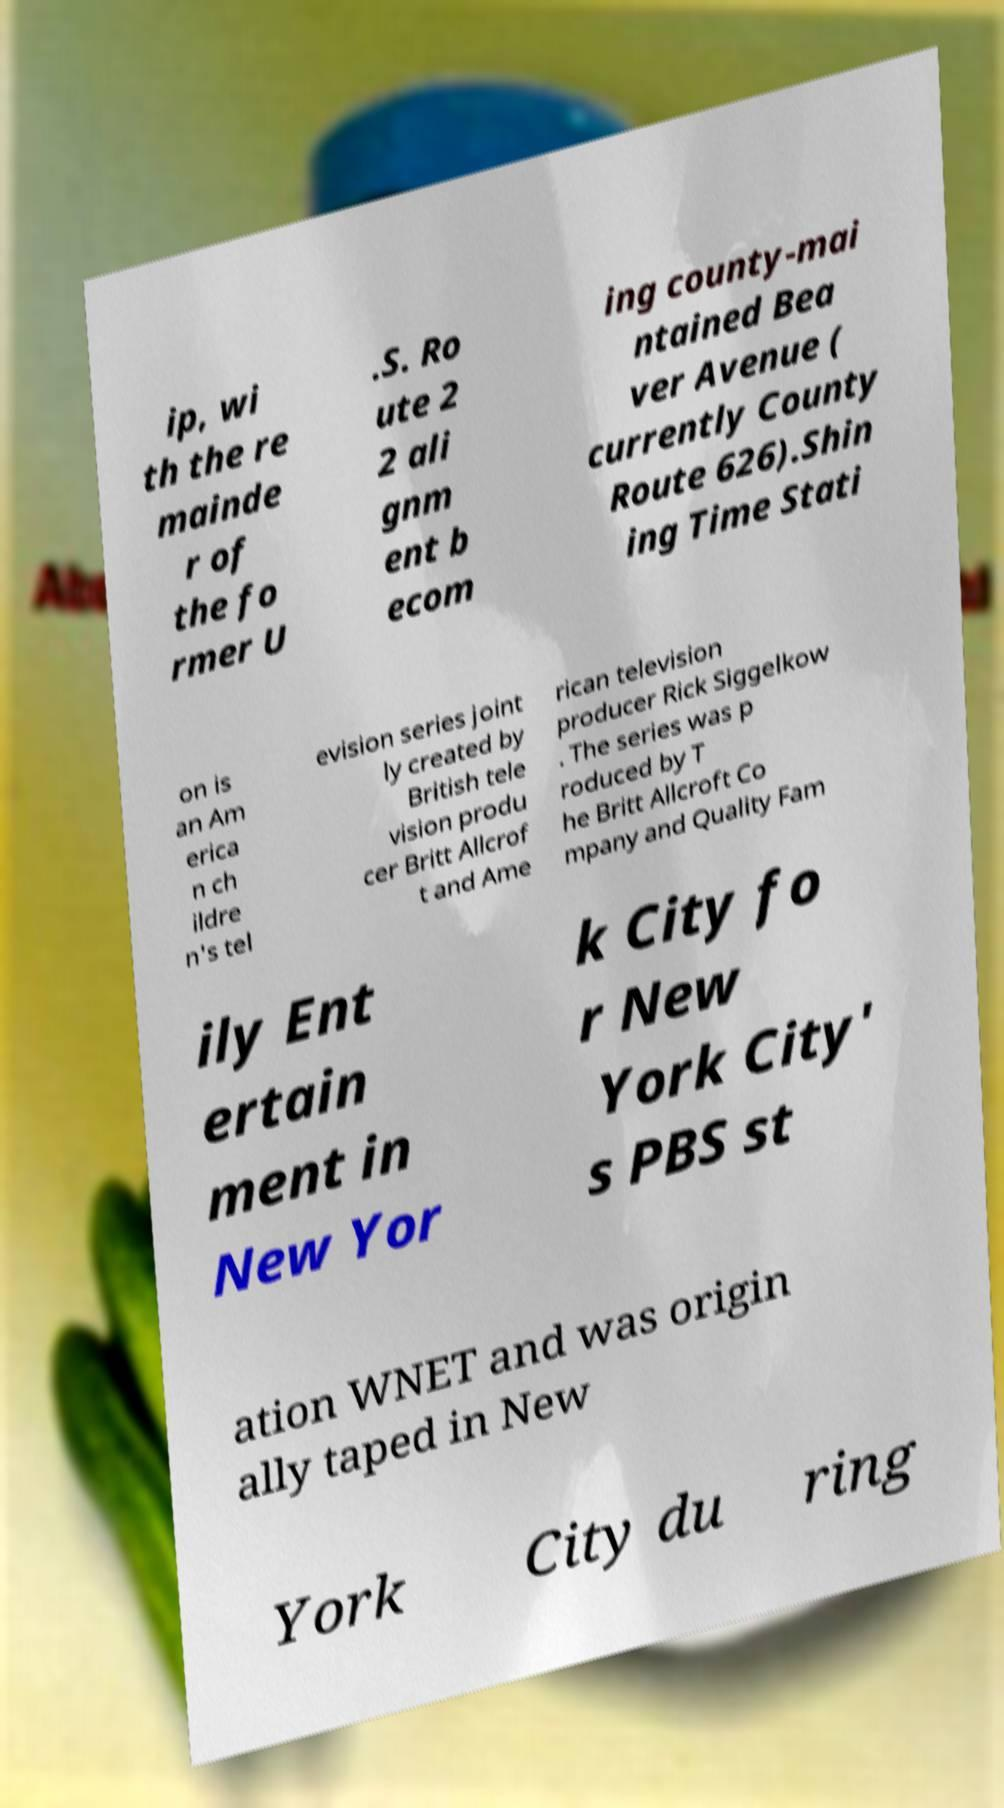Could you extract and type out the text from this image? ip, wi th the re mainde r of the fo rmer U .S. Ro ute 2 2 ali gnm ent b ecom ing county-mai ntained Bea ver Avenue ( currently County Route 626).Shin ing Time Stati on is an Am erica n ch ildre n's tel evision series joint ly created by British tele vision produ cer Britt Allcrof t and Ame rican television producer Rick Siggelkow . The series was p roduced by T he Britt Allcroft Co mpany and Quality Fam ily Ent ertain ment in New Yor k City fo r New York City' s PBS st ation WNET and was origin ally taped in New York City du ring 